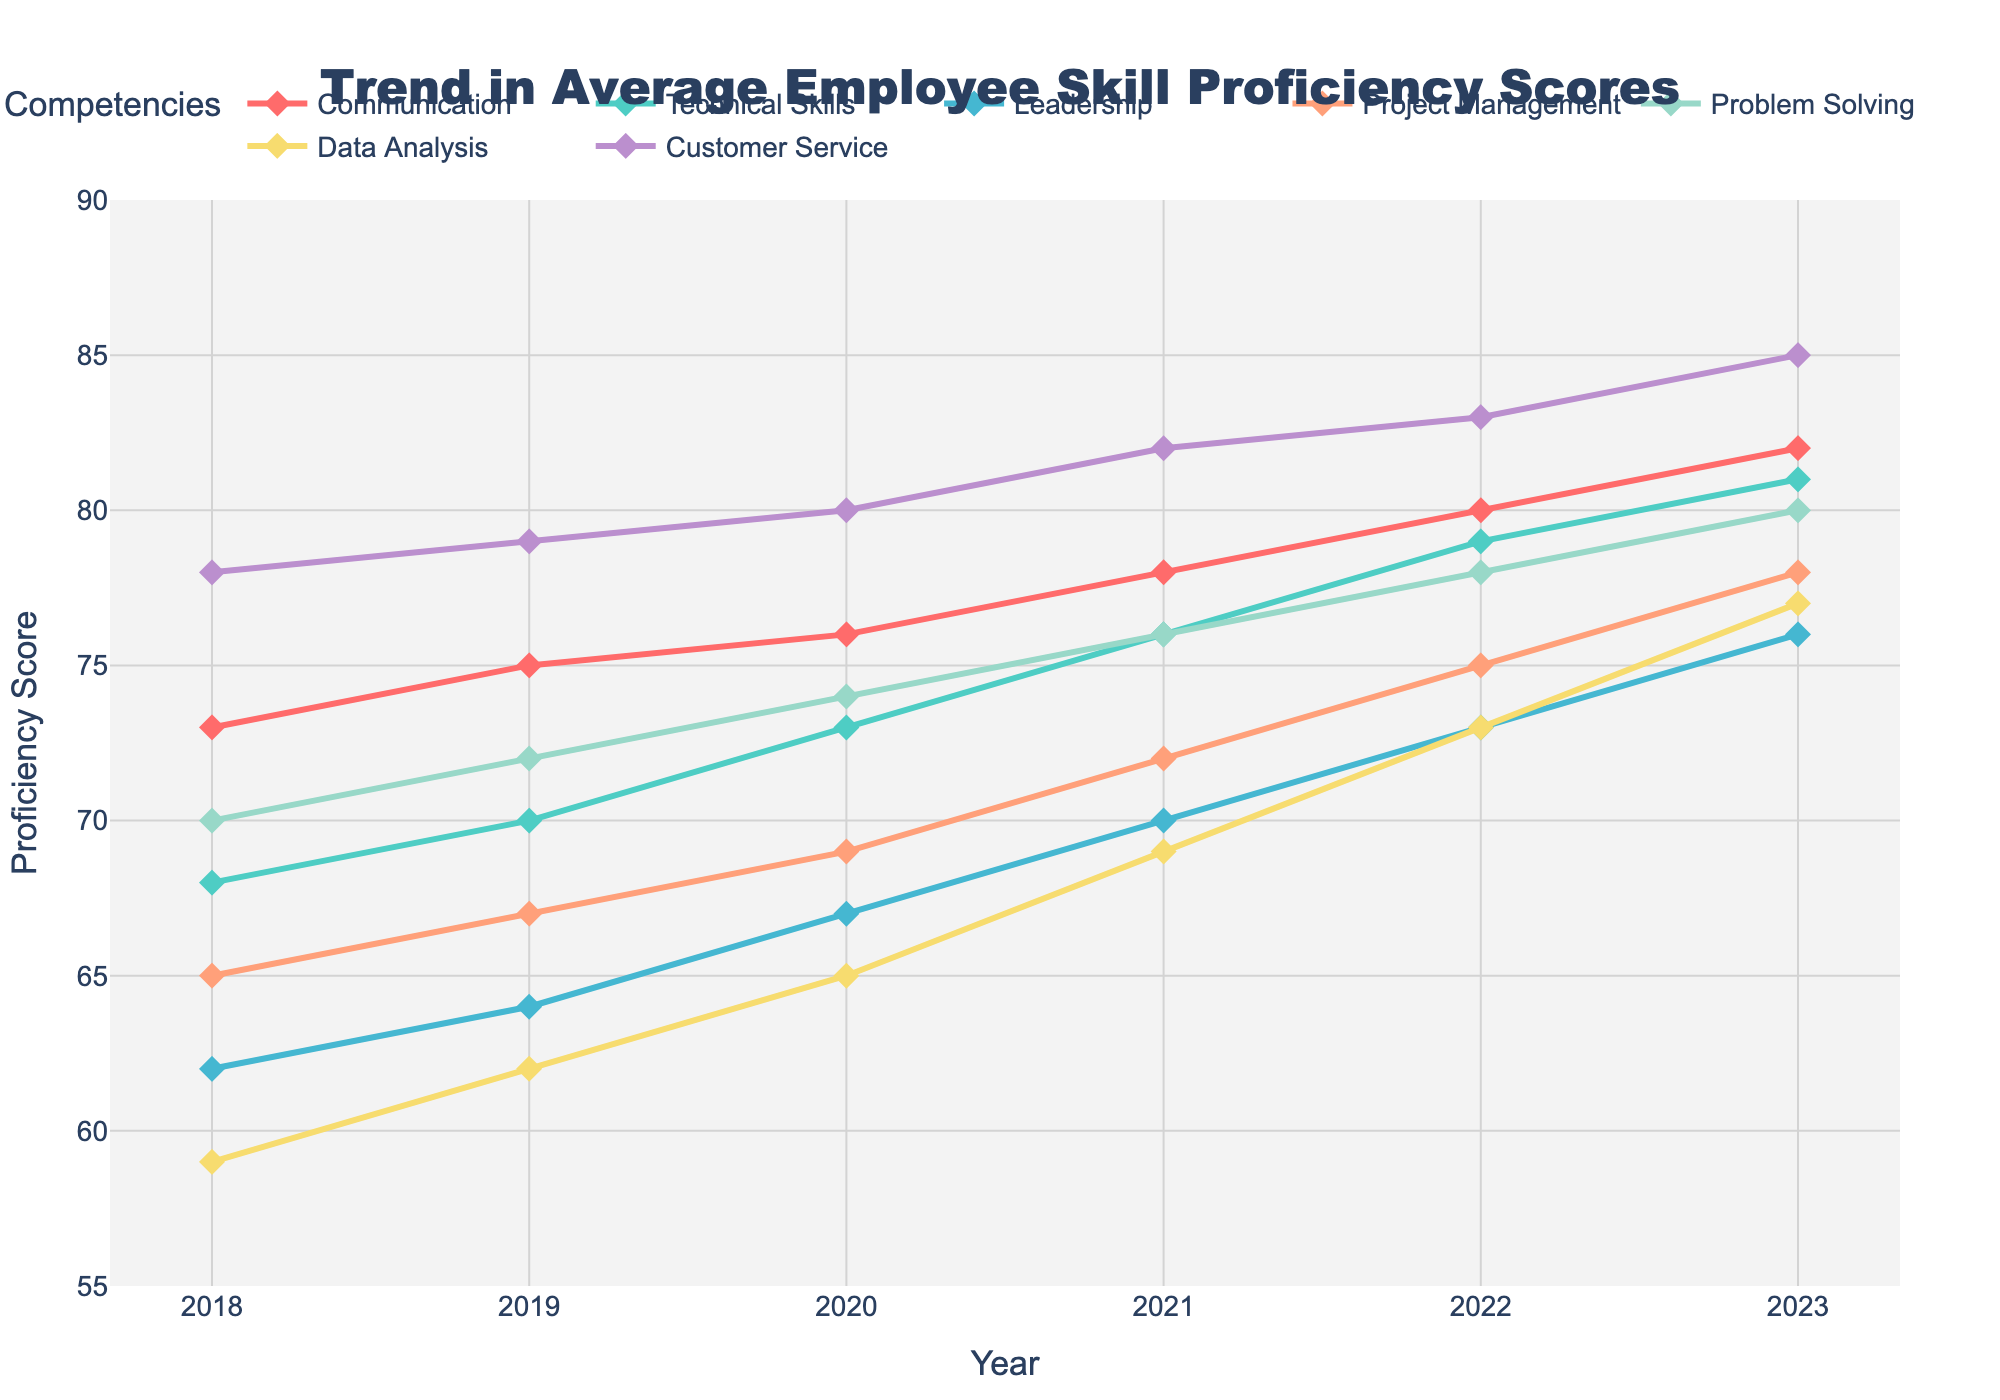Which year shows the highest average proficiency score in Technical Skills? To find the year with the highest Technical Skills proficiency score, we look at the Technical Skills line in the plot and identify the highest point along the y-axis, which is in 2023.
Answer: 2023 Which competency saw the largest improvement from 2018 to 2023? To determine which competency had the largest improvement over time, subtract the 2018 score from the 2023 score for each competency: Communication (82 - 73 = 9), Technical Skills (81 - 68 = 13), Leadership (76 - 62 = 14), Project Management (78 - 65 = 13), Problem Solving (80 - 70 = 10), Data Analysis (77 - 59 = 18), Customer Service (85 - 78 = 7). The largest increase is seen in Data Analysis.
Answer: Data Analysis Between Communication and Customer Service, which competency had slower growth from 2018 to 2023? Calculate the growth from 2018 to 2023 for each: Communication (82 - 73 = 9) and Customer Service (85 - 78 = 7). Customer Service had slower growth.
Answer: Customer Service What is the average proficiency score for Leadership in the years 2020 and 2022? Add the scores of Leadership in 2020 and 2022 then divide by 2: (67 + 73) / 2 = 70.
Answer: 70 How does the trend in Project Management scores compare to Problem Solving scores over the same period? Compare the increase in scores from 2018 to 2023 for both: Project Management (78 - 65 = 13), Problem Solving (80 - 70 = 10). Project Management has a slightly higher increase.
Answer: Project Management increased more Which year shows the closest proficiency score between Data Analysis and Leadership? By visually comparing the plot lines for the closest proximity between Data Analysis and Leadership, we find the closest scores occur in 2021.
Answer: 2021 What's the difference in the average proficiency scores of Data Analysis from 2018 to 2023? Subtract the score in 2018 from the score in 2023: 77 - 59 = 18.
Answer: 18 In which year does Technical Skills first surpass a score of 75? Look at the Technical Skills plot line and find the first year the score exceeds 75, which is 2021.
Answer: 2021 